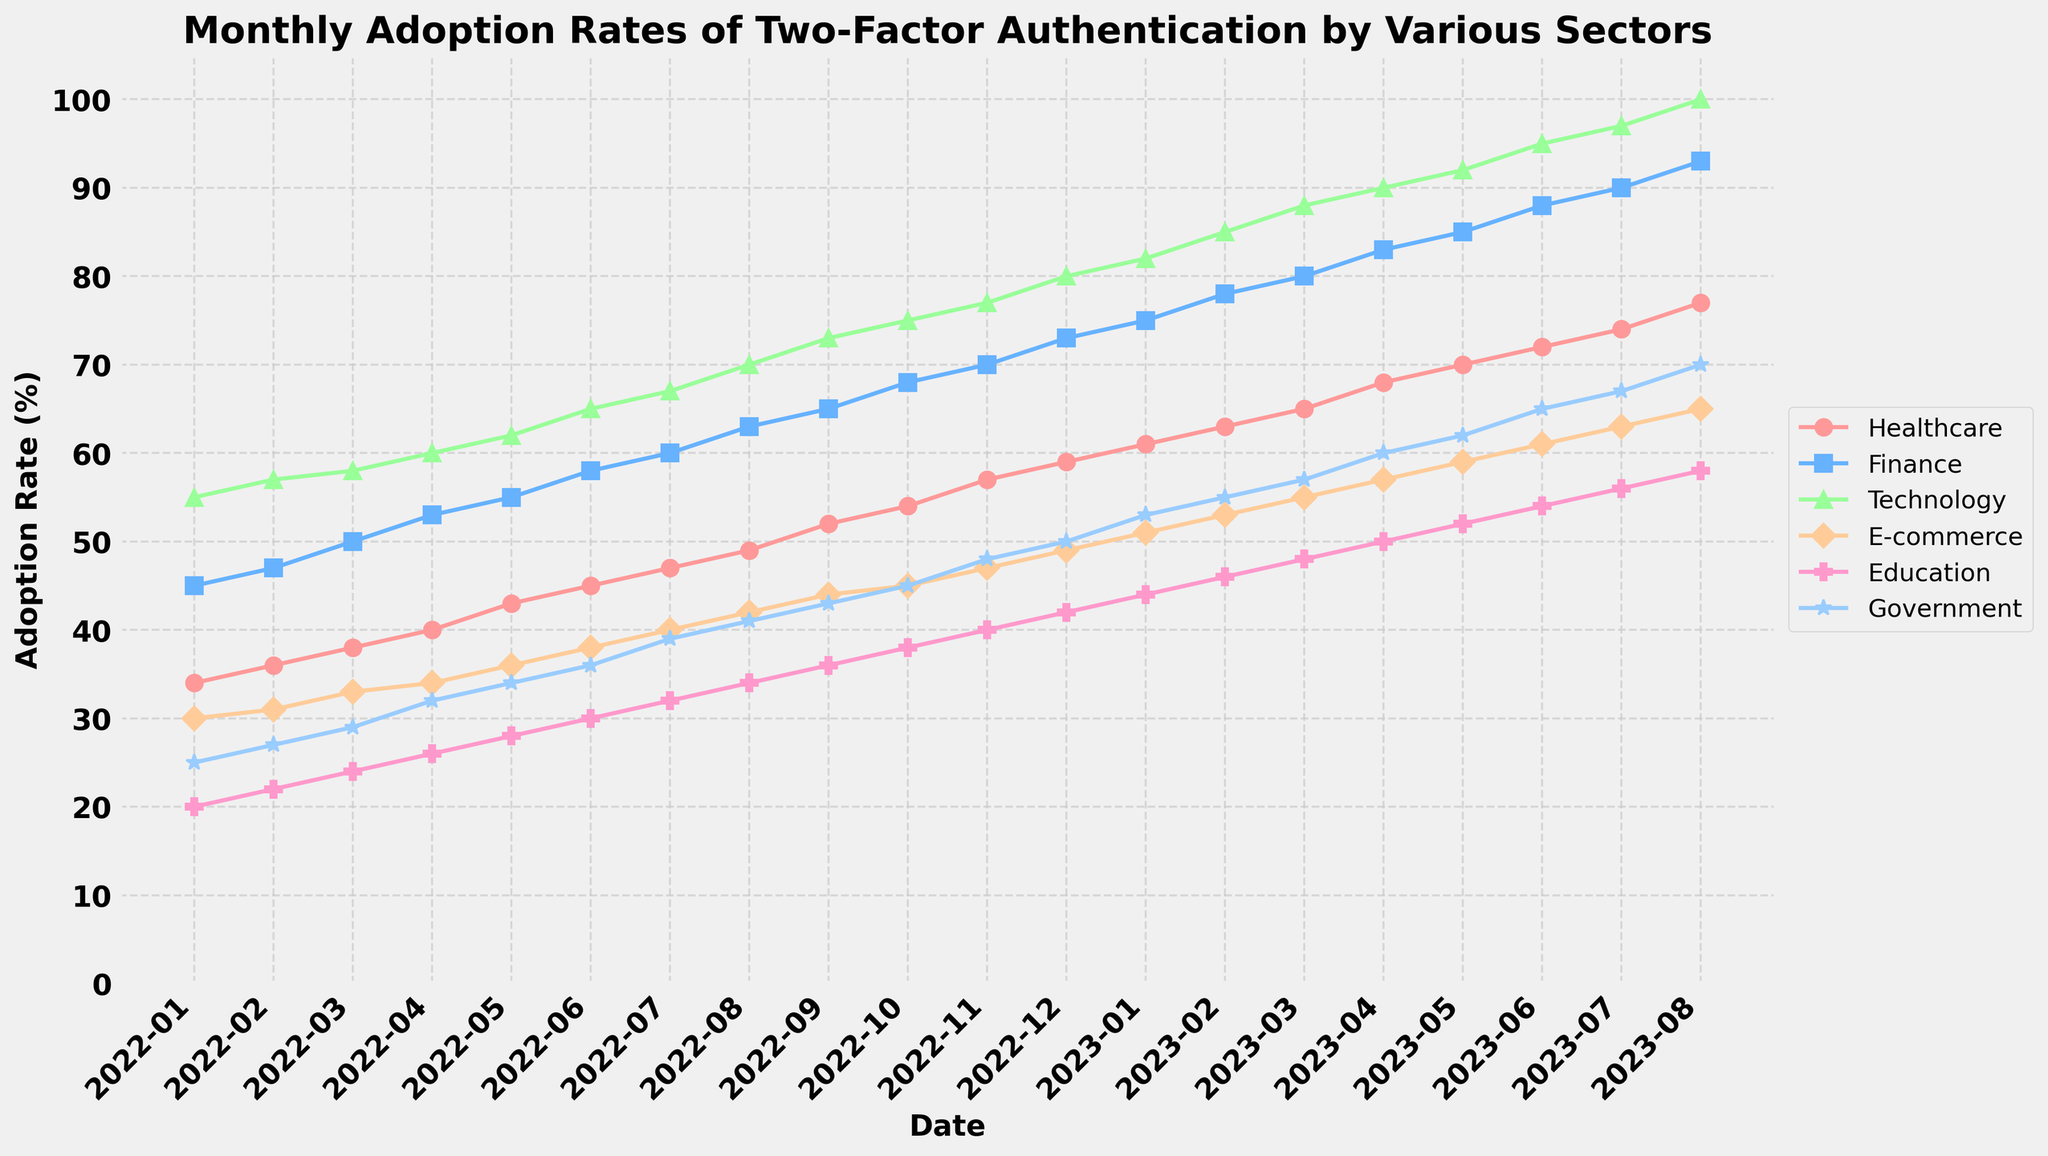what is the title of the plot? The title of the plot is clearly indicated at the top of the figure. It is formatted in a bold font to stand out.
Answer: Monthly Adoption Rates of Two-Factor Authentication by Various Sectors What is the adoption rate of two-factor authentication for the Healthcare sector in June 2022? The data point for the Healthcare sector in June 2022 is 45, as plotted on the graph. It can be found by looking at the corresponding value along the vertical axis where the Healthcare line intersects the June 2022 mark.
Answer: 45% Which sector shows the highest adoption rate in August 2023? In August 2023, the plot shows the Technology sector having the highest adoption rate as it reaches 100%, which is the maximum value on the y-axis.
Answer: Technology Which two sectors have exactly the same adoption rate in January 2023? For January 2023, the adoption rates for both the Finance and E-commerce sectors are the same, at 75%. This can be identified by observing where their respective lines intersect the January 2023 point on the x-axis.
Answer: Finance and E-commerce What is the average adoption rate of two-factor authentication for the Education sector from January to December 2022? The adoption rates for the Education sector from January to December 2022 are given in the data table. Calculating the average involves summing these values (20+22+24+26+28+30+32+34+36+38+40+42) = 372, and dividing by the number of months (12). So, the average is 372/12 = 31.
Answer: 31% By how many percentage points did the Government sector's adoption rate increase from January 2022 to August 2023? The Government sector's adoption rate in January 2022 was 25%, and in August 2023, it was 70%. The increase is calculated by subtracting the January 2022 value from the August 2023 value: 70 - 25 = 45.
Answer: 45% Which sector had the least growth in two-factor authentication adoption from January 2022 to August 2023? By comparing the difference between January 2022 and August 2023 for each sector, the Healthcare sector shows the least growth. It increased from 34% to 77%, which is an increase of 43 percentage points, which is lower than the others.
Answer: Healthcare How many sectors had an adoption rate of more than 70% in May 2023? In May 2023, from the plot, we can observe the Technology (92%), Finance (85%), E-commerce (59%), and Government (62%) sectors. So, three sectors (Healthcare, Finance, and Technology) had rates more than 70%.
Answer: 3 What is the trend in the adoption rate for the E-commerce sector over the entire time period shown in the plot? By analyzing the plot, we see that the E-commerce sector consistently increased from 30% in January 2022 to 65% in August 2023. The increasing trend is steady and upward.
Answer: Increasing When did the Finance sector's adoption rate first surpass 60%? Observing the Finance sector's line, it first surpasses 60% in July 2022. This can be checked by finding the point on the Finance line when it first crosses above the 60% mark on the y-axis.
Answer: July 2022 